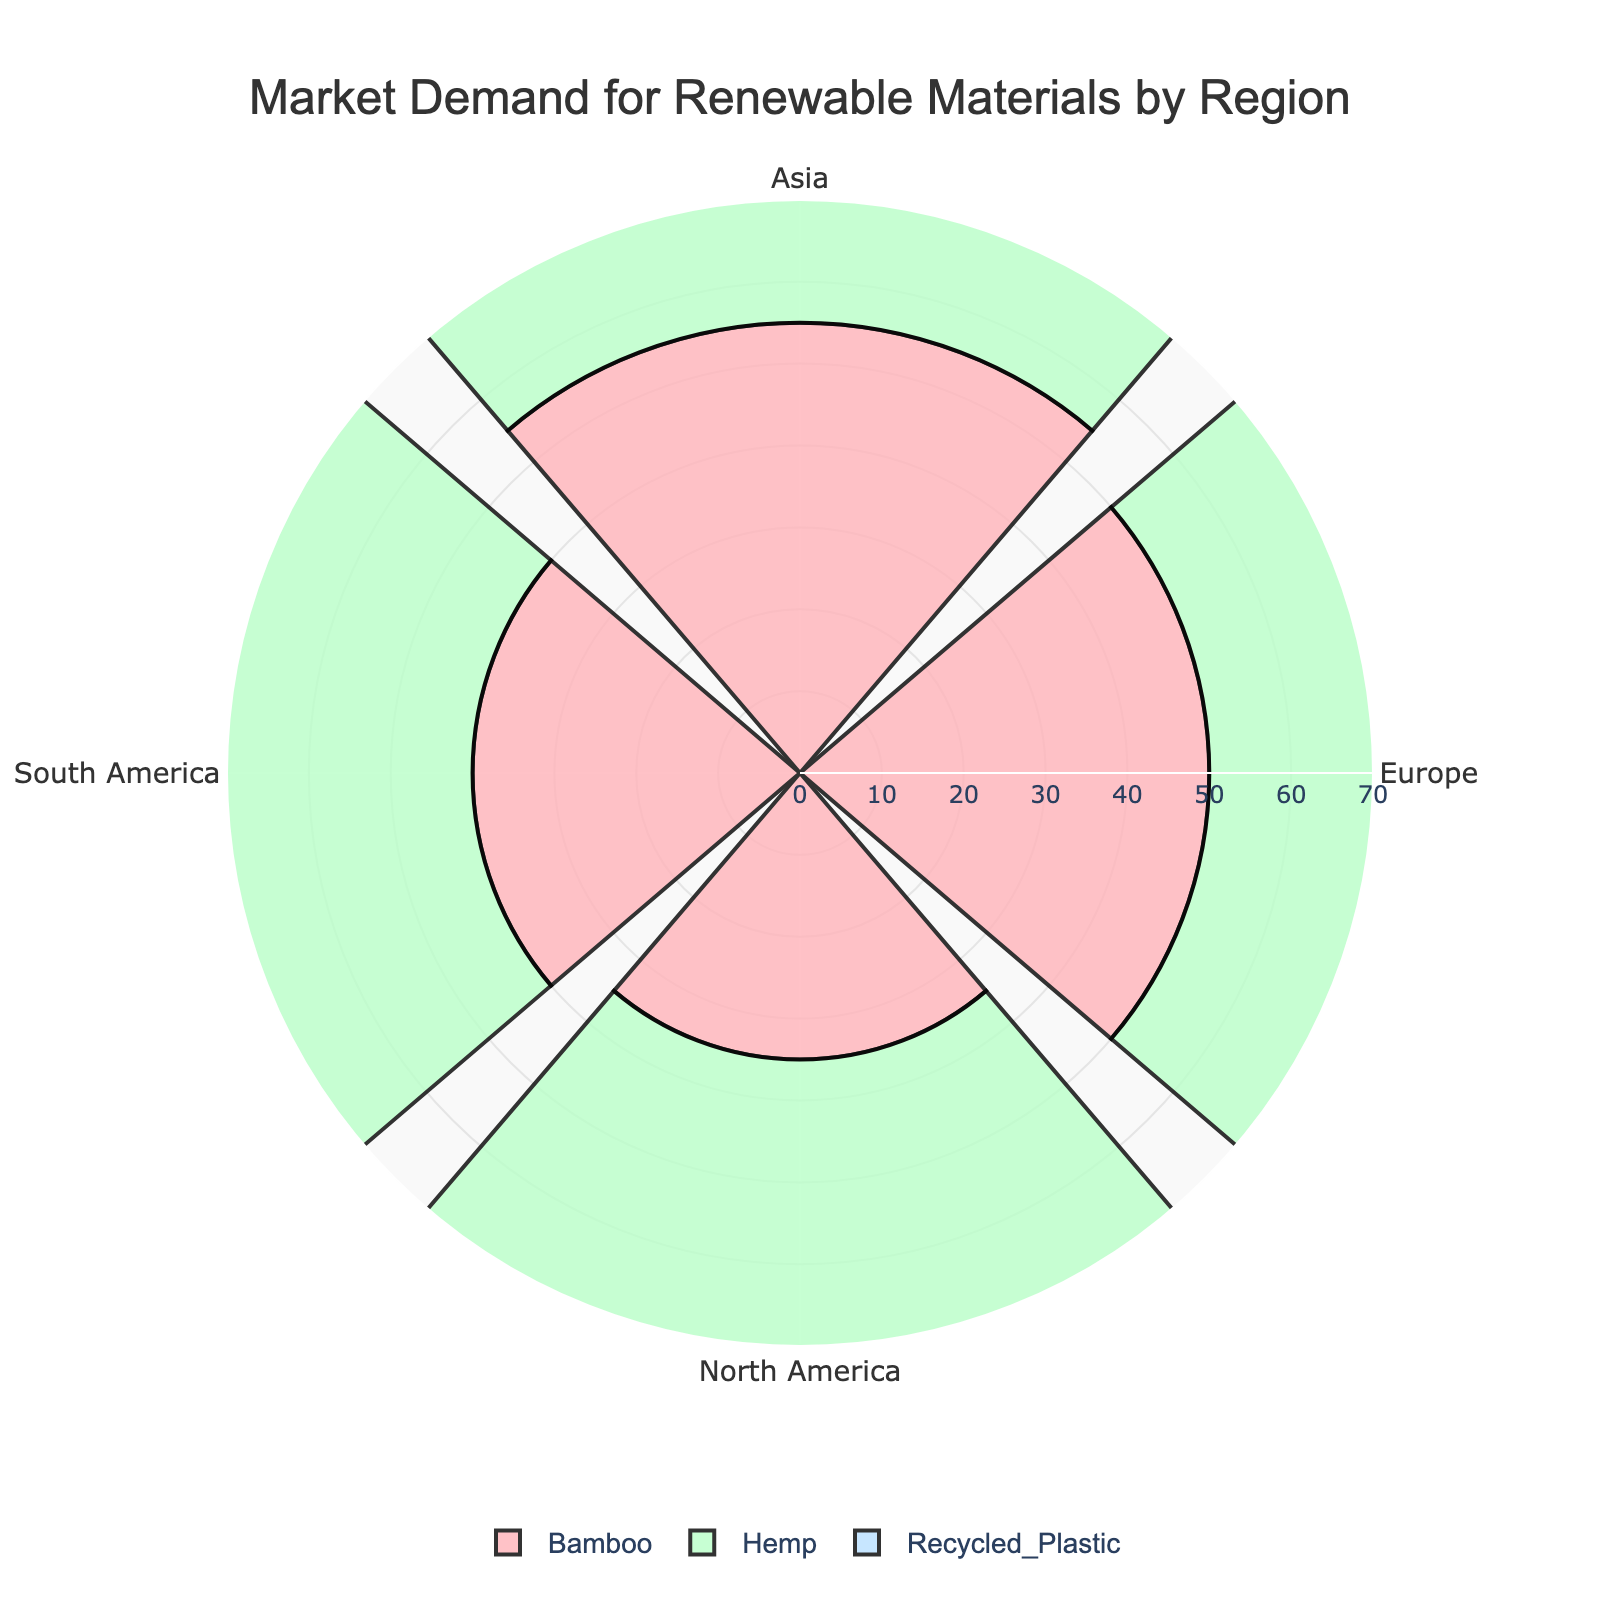What is the title of the figure? The title is typically found at the top of the chart. On this figure, it reads "Market Demand for Renewable Materials by Region.”
Answer: Market Demand for Renewable Materials by Region Which region has the highest market demand for Bamboo? Look at the segments labeled "Bamboo" across the regions. Compare their lengths to identify the biggest one. Asia has the longest segment for Bamboo.
Answer: Asia Which material type has the highest overall market demand in Europe? Identify the segments for each material type in Europe and compare their lengths. The longer the segment, the higher the market demand. Bamboo has the longest segment in Europe.
Answer: Bamboo What is the combined market demand for Hemp in North America and Europe? Identify the lengths of the Hemp segments for both North America and Europe. Add the two values. North America has 45 and Europe has 30, thus 45 + 30.
Answer: 75 Which region shows equal market demand for Bamboo and Recycled Plastic? Look for regions where the length of the Bamboo and Recycled Plastic segments are the same. In North America, both Bamboo and Recycled Plastic have a demand of 40.
Answer: North America Which material type sees the highest variance in market demand across the regions? Observe the lengths of each material type across regions and identify which type has the widest range. Hemp goes from 30 in Europe to 60 in Asia.
Answer: Hemp In which region is the market demand for Recycled Plastic lower than Bamboo but higher than Hemp? Compare the lengths of segments within each region. In South America, Bamboo is 40, Recycled Plastic is 30, and Hemp is 50. This doesn’t meet the criteria. The correct region is North America: Bamboo is 35, Recycled Plastic is 40, and Hemp is 45.
Answer: North America 